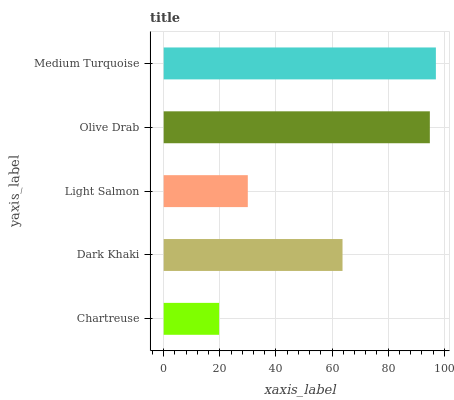Is Chartreuse the minimum?
Answer yes or no. Yes. Is Medium Turquoise the maximum?
Answer yes or no. Yes. Is Dark Khaki the minimum?
Answer yes or no. No. Is Dark Khaki the maximum?
Answer yes or no. No. Is Dark Khaki greater than Chartreuse?
Answer yes or no. Yes. Is Chartreuse less than Dark Khaki?
Answer yes or no. Yes. Is Chartreuse greater than Dark Khaki?
Answer yes or no. No. Is Dark Khaki less than Chartreuse?
Answer yes or no. No. Is Dark Khaki the high median?
Answer yes or no. Yes. Is Dark Khaki the low median?
Answer yes or no. Yes. Is Olive Drab the high median?
Answer yes or no. No. Is Medium Turquoise the low median?
Answer yes or no. No. 